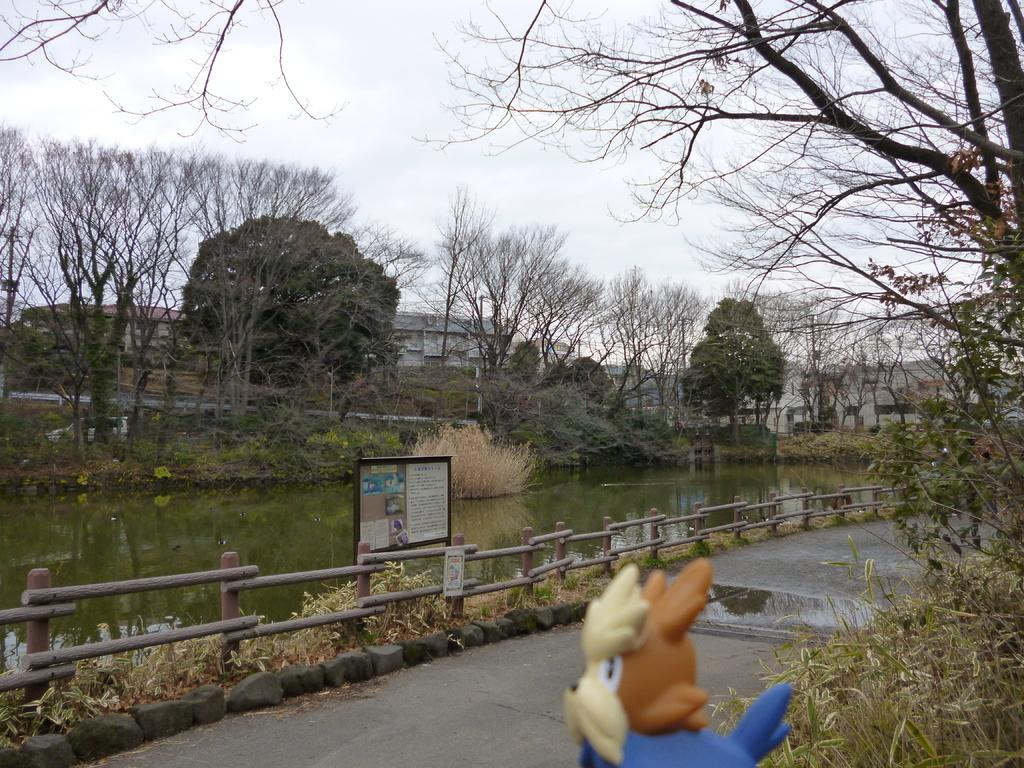What type of natural feature is present in the image? There is a lake in the image. What type of vegetation can be seen in the image? There are trees in the image. What type of man-made structures are visible in the image? There are buildings in the image. What type of watch can be seen on the trees in the image? There are no watches present in the image; it features a lake, trees, and buildings. What type of acoustics can be heard from the buildings in the image? The image does not provide any information about the acoustics of the buildings. 